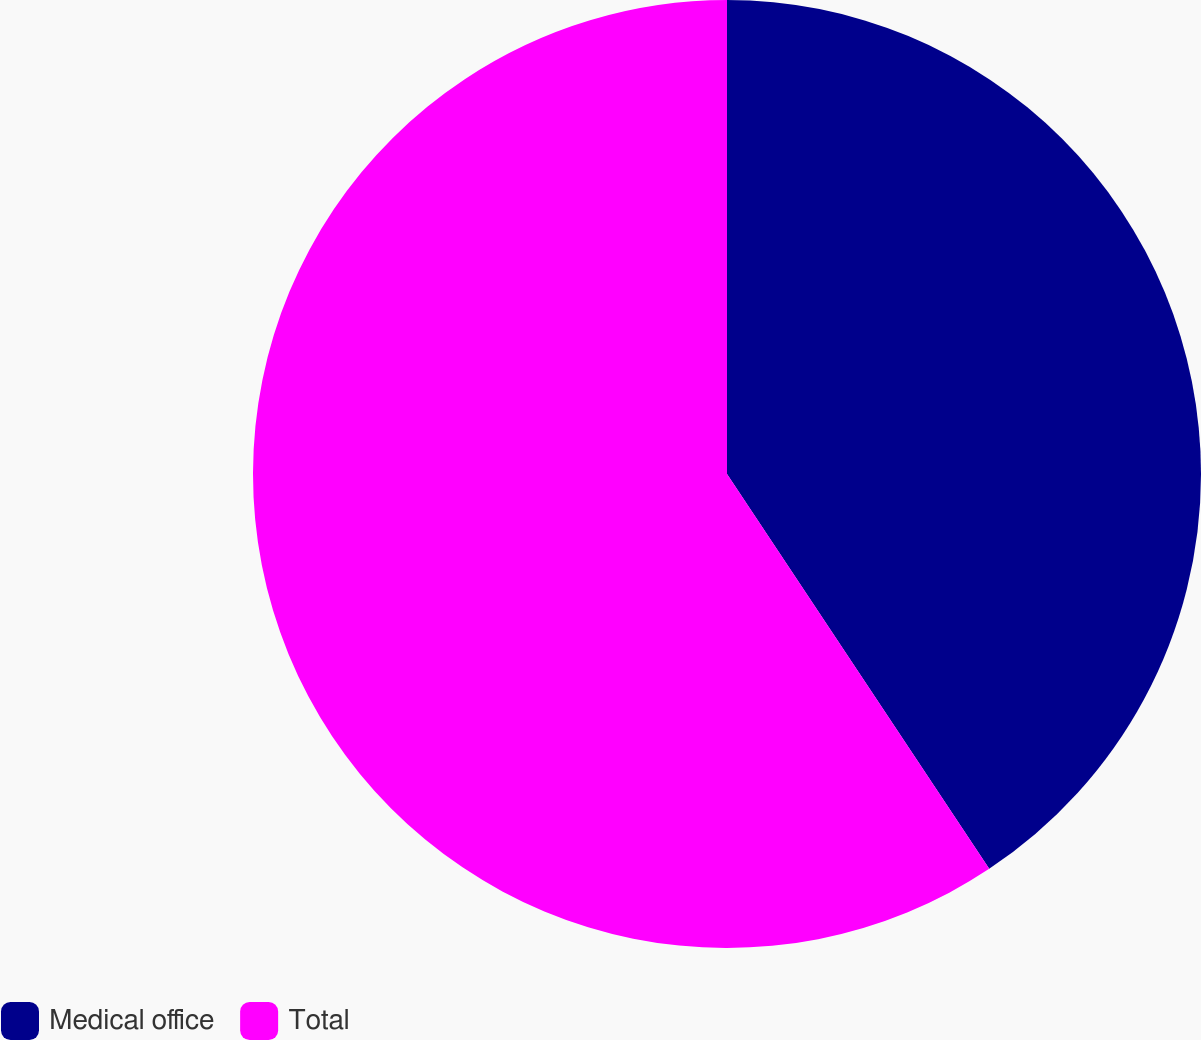Convert chart. <chart><loc_0><loc_0><loc_500><loc_500><pie_chart><fcel>Medical office<fcel>Total<nl><fcel>40.67%<fcel>59.33%<nl></chart> 